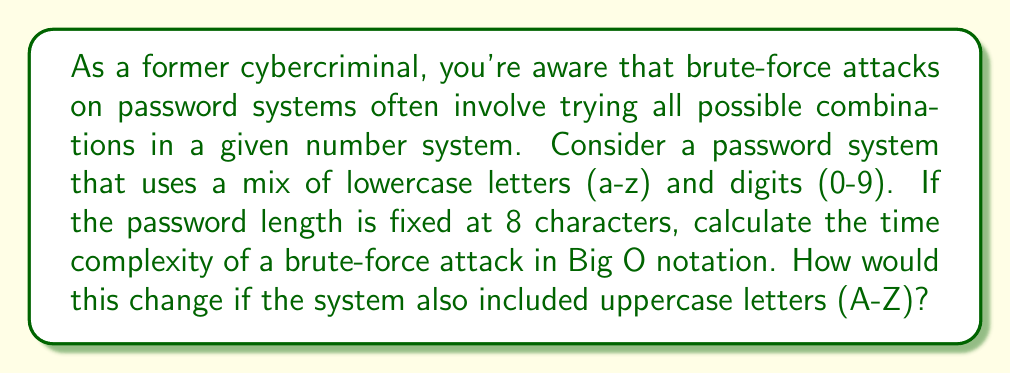Solve this math problem. To solve this problem, we need to consider the number of possible characters and the length of the password:

1. For lowercase letters and digits:
   - Number of possible characters: 26 (a-z) + 10 (0-9) = 36
   - Password length: 8

   The total number of possible combinations is:
   $$36^8 = 2,821,109,907,456$$

2. Time complexity:
   In Big O notation, we express this as $O(n^m)$, where $n$ is the number of possible characters and $m$ is the password length.

   For the given case: $O(36^8)$

3. Including uppercase letters:
   - Number of possible characters: 26 (a-z) + 26 (A-Z) + 10 (0-9) = 62
   - Password length: 8

   The new time complexity would be: $O(62^8)$

The time complexity in Big O notation remains $O(n^m)$ in both cases, but the actual number of operations increases significantly when uppercase letters are added.

To illustrate the difference:
$$36^8 = 2,821,109,907,456$$
$$62^8 = 218,340,105,584,896$$

This shows that adding uppercase letters increases the number of possible combinations by a factor of approximately 77.4, making the brute-force attack much more time-consuming.
Answer: Time complexity without uppercase letters: $O(36^8)$
Time complexity with uppercase letters: $O(62^8)$
Both can be generalized as $O(n^m)$, where $n$ is the number of possible characters and $m$ is the password length. 